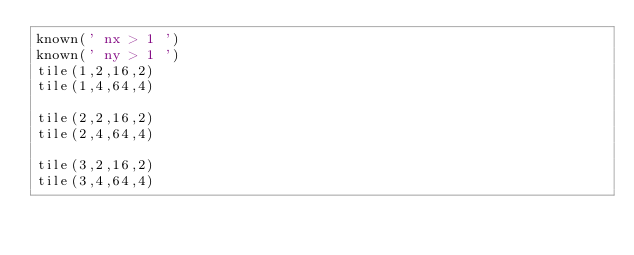Convert code to text. <code><loc_0><loc_0><loc_500><loc_500><_Python_>known(' nx > 1 ')
known(' ny > 1 ')
tile(1,2,16,2)
tile(1,4,64,4)

tile(2,2,16,2)
tile(2,4,64,4)

tile(3,2,16,2)
tile(3,4,64,4)

</code> 